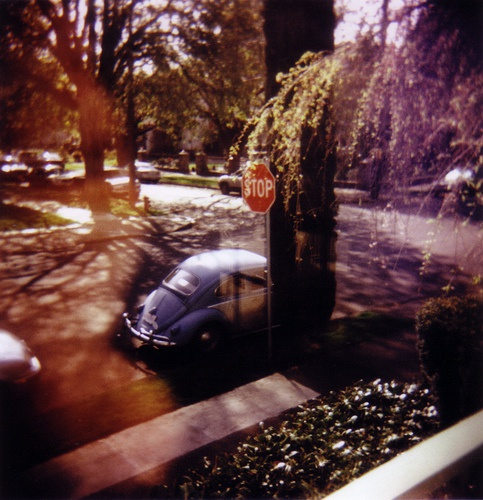Describe the objects in this image and their specific colors. I can see car in black, lavender, purple, and maroon tones, car in black, maroon, lavender, and brown tones, stop sign in black, brown, and tan tones, car in black, brown, maroon, and lavender tones, and car in black, maroon, lavender, and brown tones in this image. 